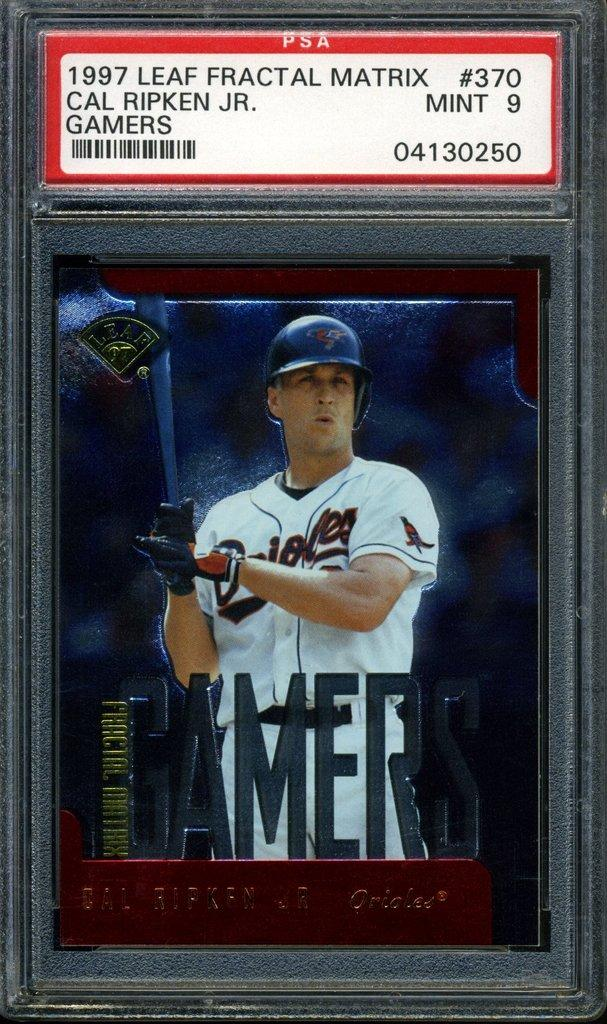<image>
Describe the image concisely. Baseball card which says Gamers on it in the front. 